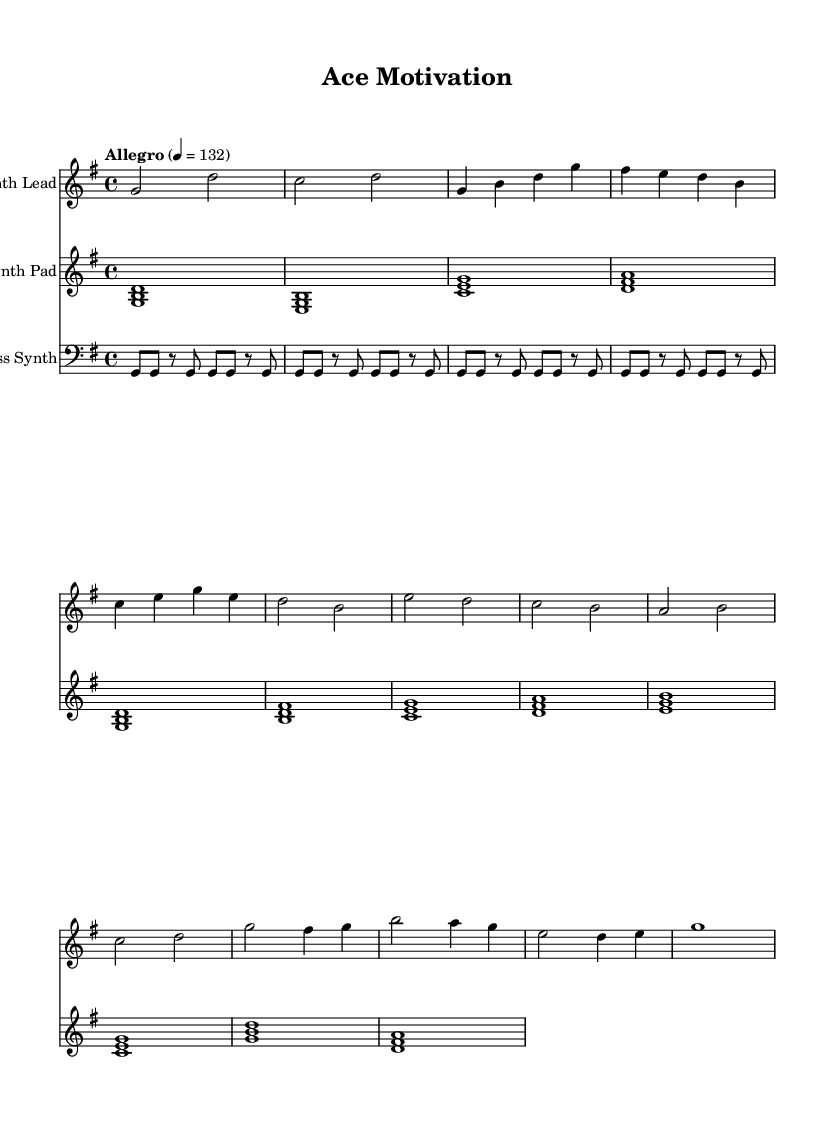What is the key signature of this music? The key signature is based on the number of sharps or flats indicated at the beginning of the staff. In this case, there is an “F#” noted, indicating it is in G major, which has one sharp.
Answer: G major What is the time signature of this music? The time signature is located at the beginning of the piece, represented as two numbers stacked vertically. Here, it shows "4/4," which means there are four beats per measure.
Answer: 4/4 What is the marked tempo for this music? The tempo marking is indicated at the beginning of the score. It is shown with the word "Allegro" and the tempo value "4 = 132," denoting a fast pace for the piece.
Answer: Allegro What is the length of the chorus section? The chorus section can be identified by looking at the repeated patterns or distinct sections. In this case, the chorus features a distinct melodic line that spans 4 measures.
Answer: 4 measures How many staff sections are present in this music? The number of staff sections can be counted by assessing the layout of the score. There are three distinct staff sections: one for Synth Lead, one for Synth Pad, and one for Bass Synth.
Answer: Three Which instrument plays the lead melody? The instrument playing the lead melody is specified in the score with the label “Synth Lead” above the respective staff. This label indicates that it is responsible for the higher melodic content.
Answer: Synth Lead What type of electronic music is represented in this score? The character and structure of the rhythmic patterns, alongside the synthesized sounds, suggest a general upbeat electronic style, typically associated with dance or motivational music, designed for energizing settings.
Answer: Upbeat electronic 